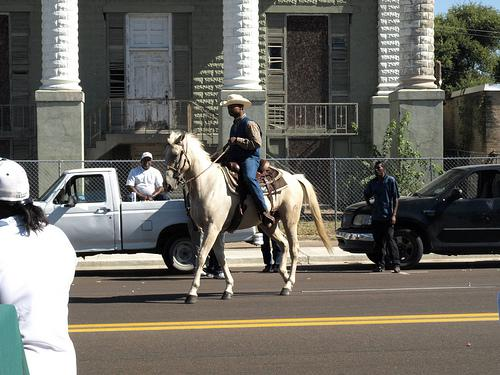Question: when was the picture taken?
Choices:
A. Evening.
B. Nighttime.
C. Morning.
D. Daytime.
Answer with the letter. Answer: D Question: how many people are in the picture?
Choices:
A. 4.
B. 8.
C. 7.
D. 9.
Answer with the letter. Answer: A Question: what color is the horse?
Choices:
A. Black.
B. Tan.
C. White.
D. Cream.
Answer with the letter. Answer: B Question: how many white columns are there?
Choices:
A. 8.
B. 7.
C. 9.
D. 3.
Answer with the letter. Answer: D Question: what animals is in the picture?
Choices:
A. Zebra.
B. Giraffe.
C. Hippo.
D. Horse.
Answer with the letter. Answer: D Question: where is the saddle located?
Choices:
A. On horse.
B. Under the horse.
C. Back of the horse.
D. In front of the horse.
Answer with the letter. Answer: A 